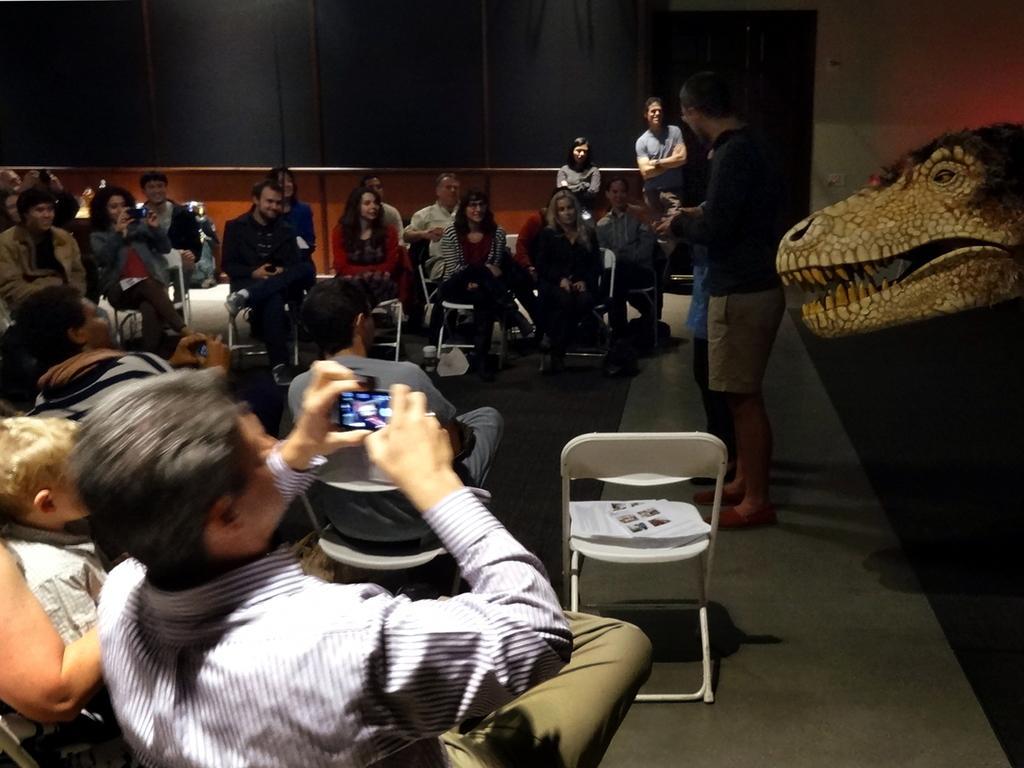Describe this image in one or two sentences. In this image i can see a group of people sitting in a chair the man sitting here holding a camera at the back ground i can see a wall. 